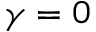Convert formula to latex. <formula><loc_0><loc_0><loc_500><loc_500>\gamma = 0</formula> 